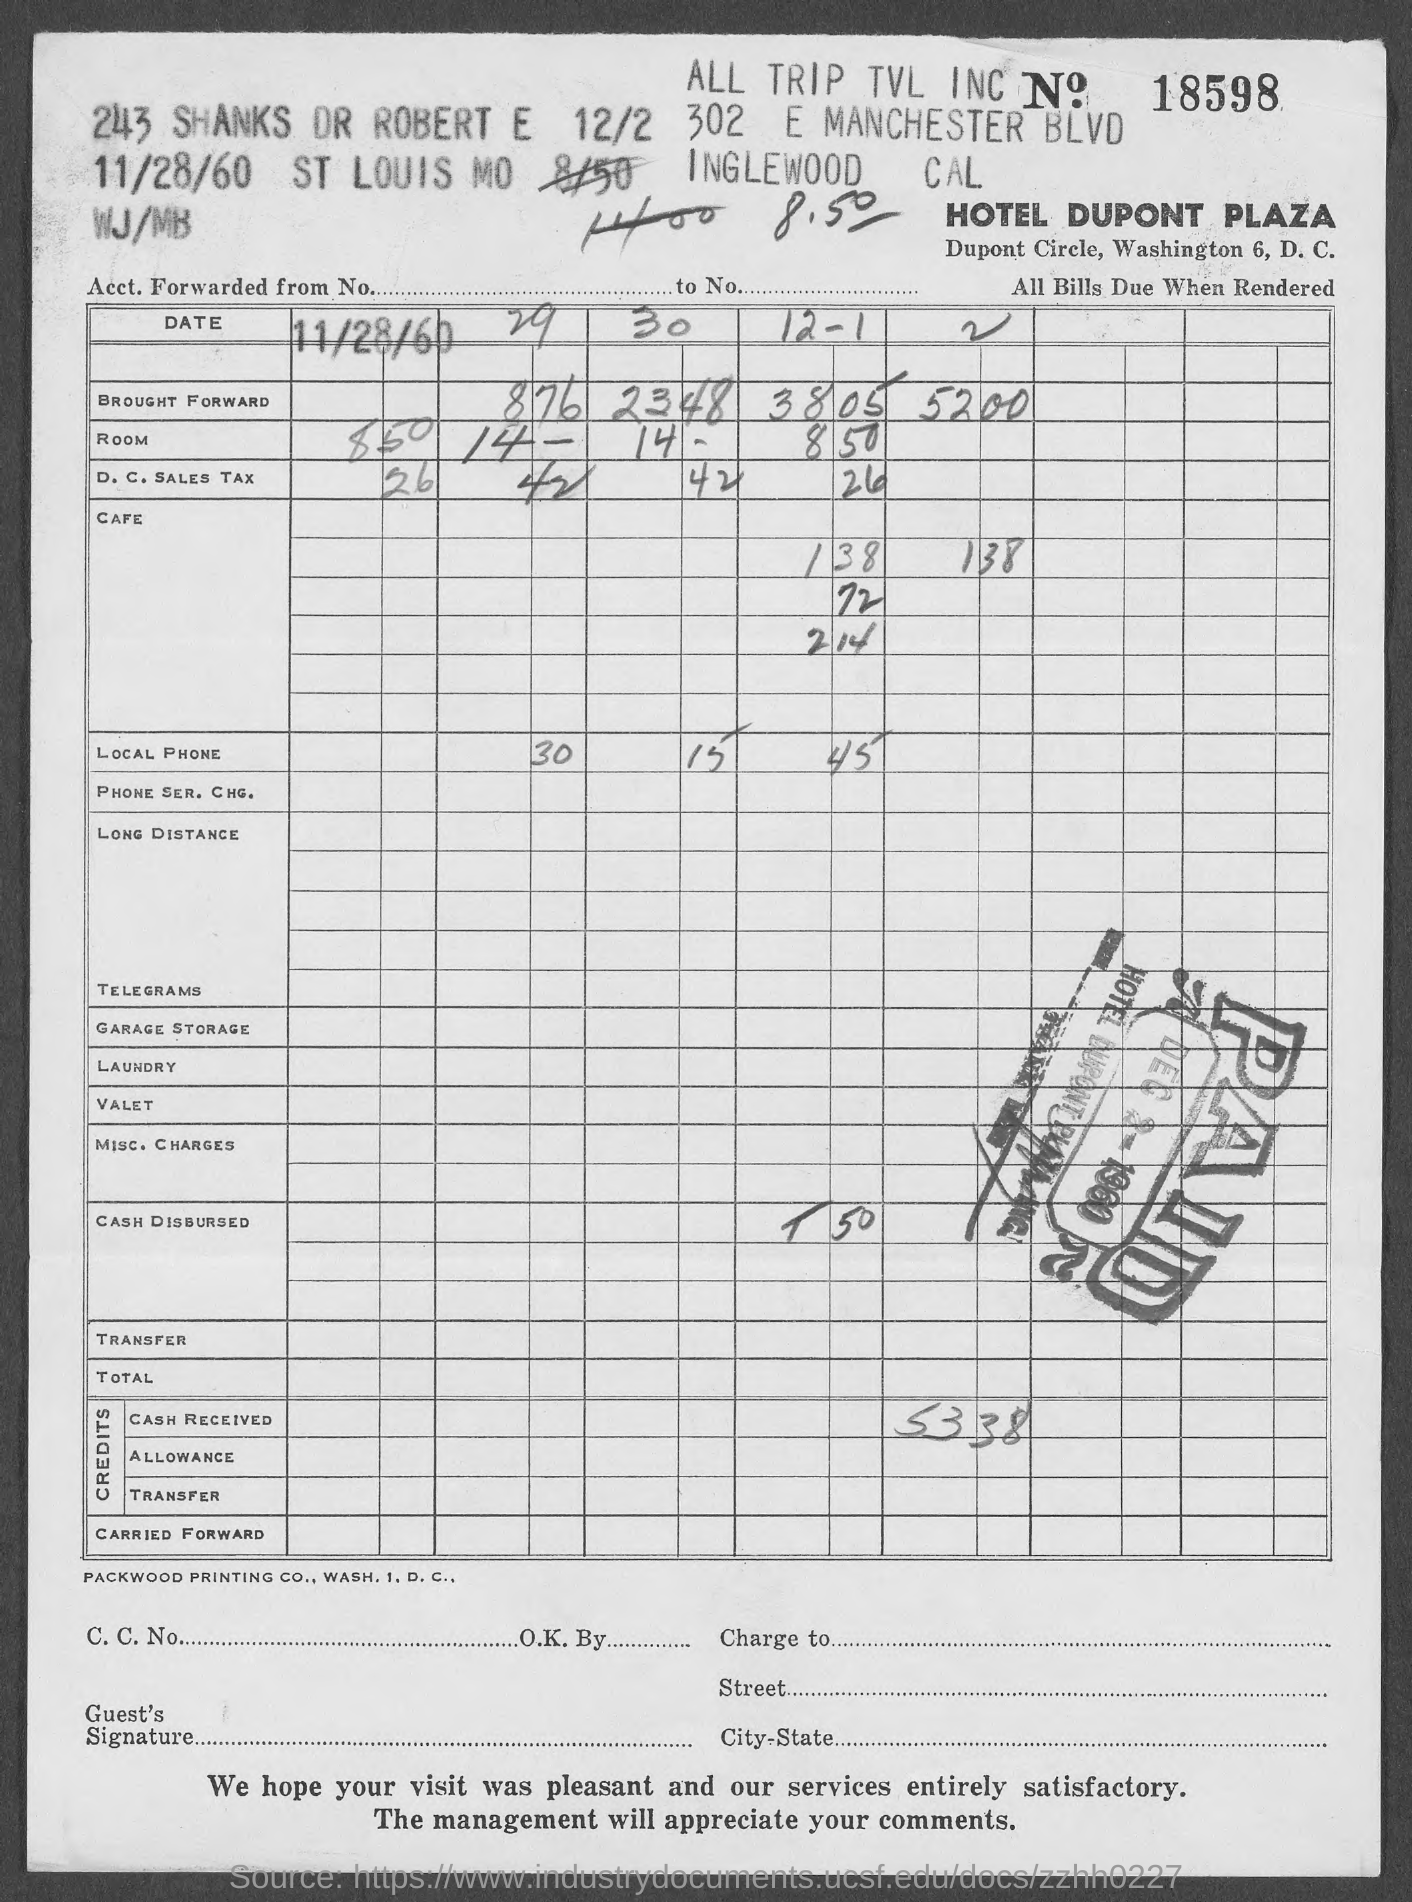Indicate a few pertinent items in this graphic. Which bill is it? 18598... The hotel bill for Hotel Dupont Plaza is provided. The bill date is November 28, 1960. 